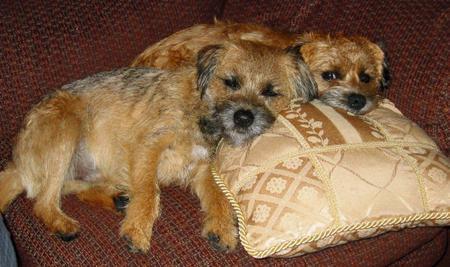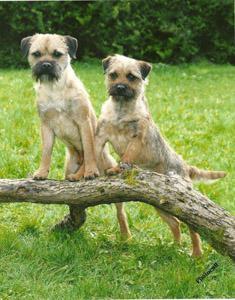The first image is the image on the left, the second image is the image on the right. For the images displayed, is the sentence "Two terriers are standing in the grass with their front paws on a branch." factually correct? Answer yes or no. Yes. The first image is the image on the left, the second image is the image on the right. Assess this claim about the two images: "At least one image shows two dogs napping together.". Correct or not? Answer yes or no. Yes. 